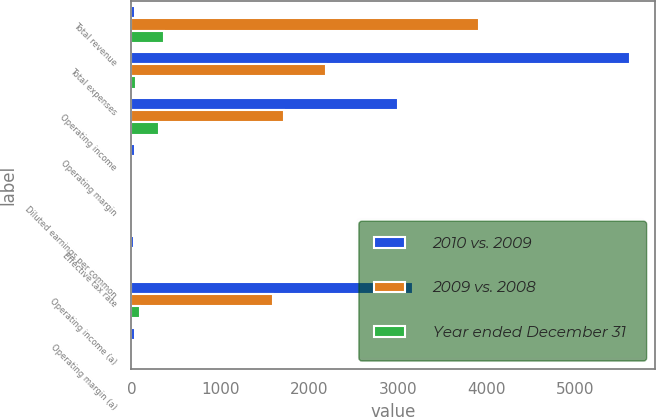<chart> <loc_0><loc_0><loc_500><loc_500><stacked_bar_chart><ecel><fcel>Total revenue<fcel>Total expenses<fcel>Operating income<fcel>Operating margin<fcel>Diluted earnings per common<fcel>Effective tax rate<fcel>Operating income (a)<fcel>Operating margin (a)<nl><fcel>2010 vs. 2009<fcel>39.3<fcel>5614<fcel>2998<fcel>34.8<fcel>10.55<fcel>32<fcel>3167<fcel>39.3<nl><fcel>2009 vs. 2008<fcel>3912<fcel>2192<fcel>1720<fcel>7.6<fcel>4.44<fcel>2<fcel>1597<fcel>1.1<nl><fcel>Year ended December 31<fcel>364<fcel>49<fcel>315<fcel>4.3<fcel>0.33<fcel>3<fcel>92<fcel>0.5<nl></chart> 